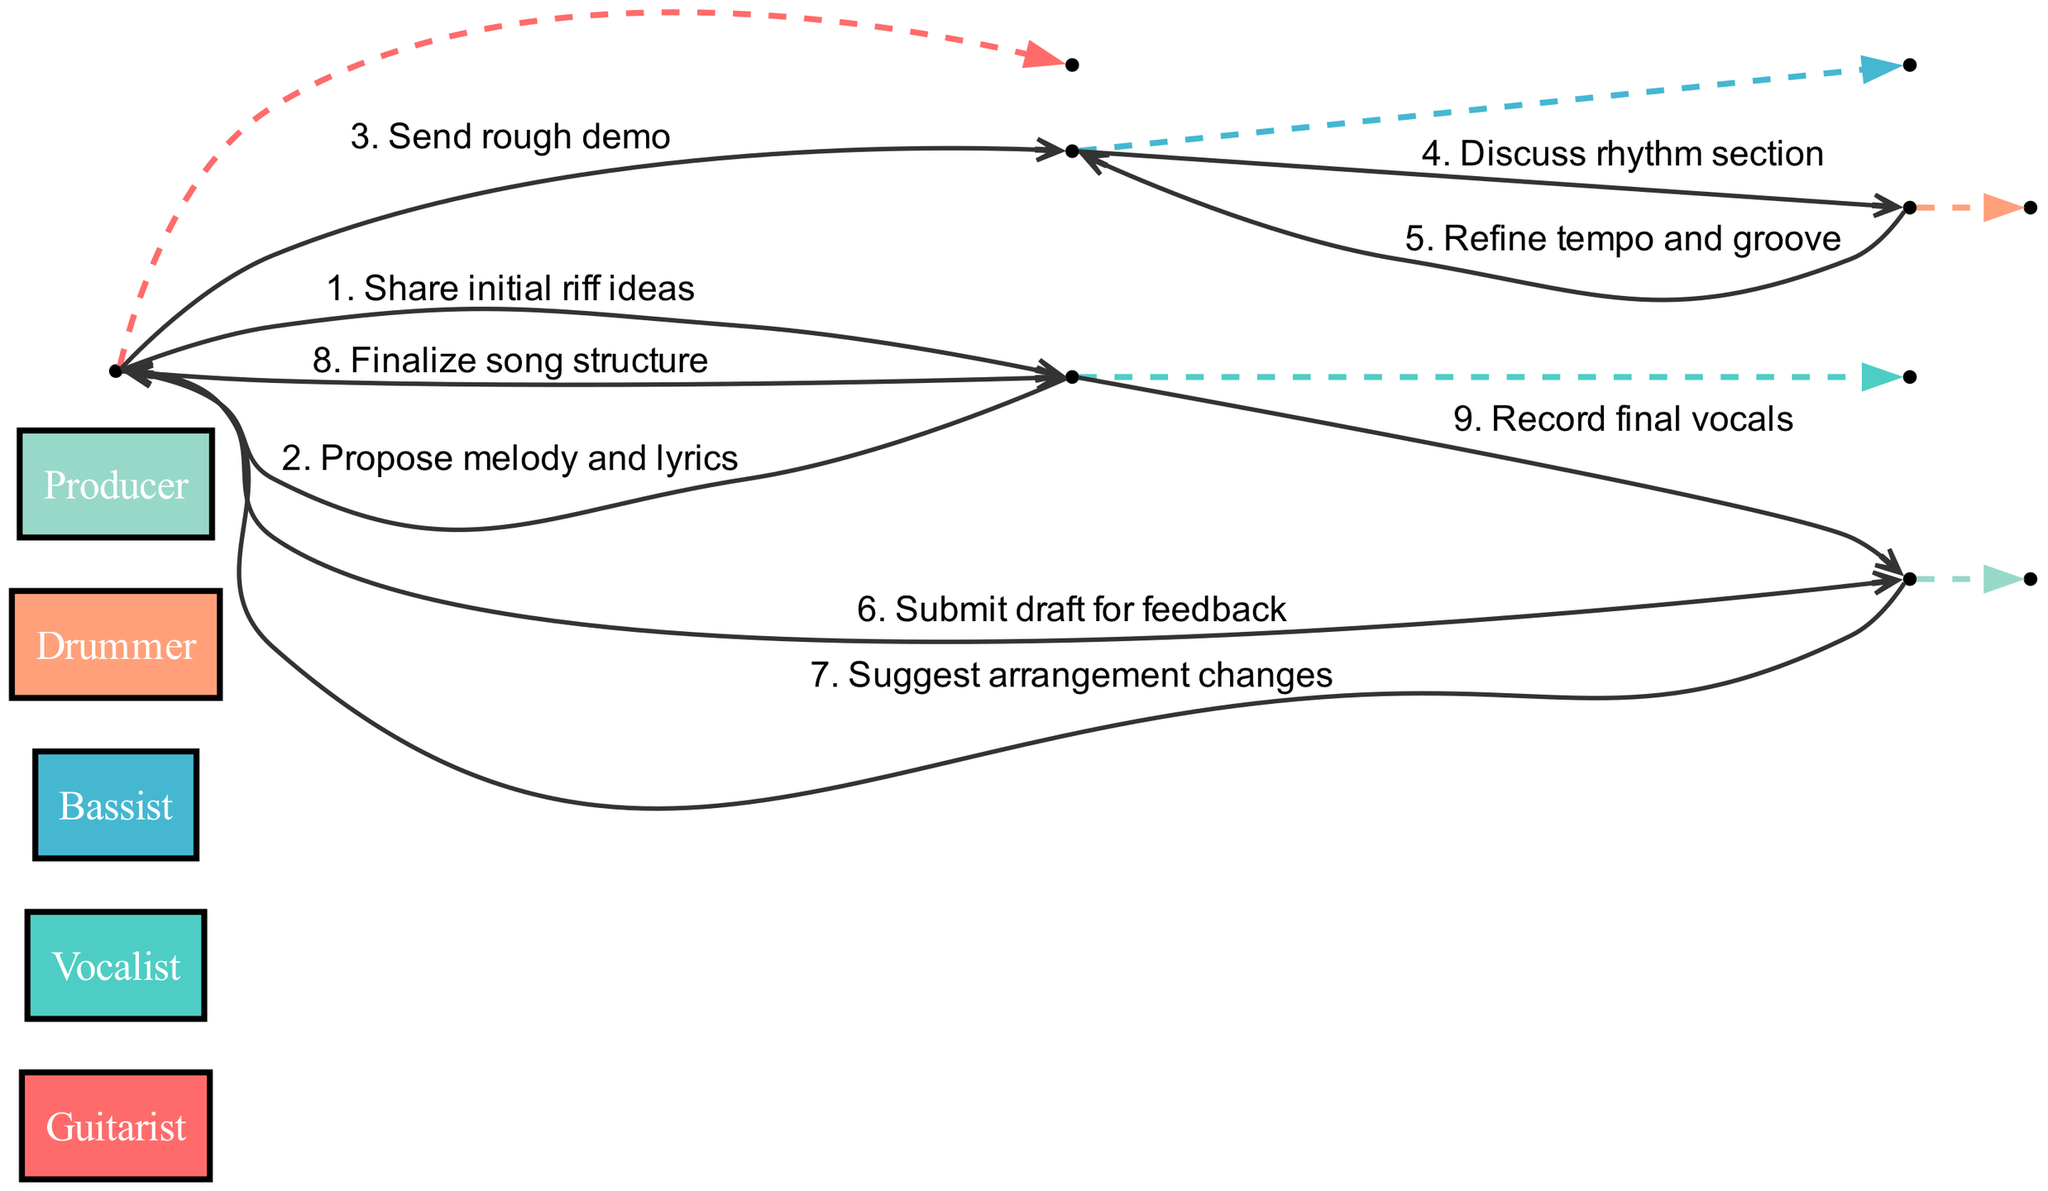What is the first message in the sequence? The first message is from the Guitarist to the Vocalist, indicating that the Guitarist shares initial riff ideas.
Answer: Share initial riff ideas How many actors are involved in the collaboration? There are five actors involved in the collaboration, which are the Guitarist, Vocalist, Bassist, Drummer, and Producer.
Answer: Five Who proposes the melody and lyrics? The Vocalist is the one who proposes the melody and lyrics to the Guitarist.
Answer: Vocalist What is the fifth message in the sequence? The fifth message is about the Drummer refining the tempo and groove after discussing the rhythm section with the Bassist.
Answer: Refine tempo and groove Which actor sends a rough demo? The Guitarist sends the rough demo to the Bassist as part of the collaboration workflow.
Answer: Guitarist What is the final action taken by the Vocalist? The final action taken by the Vocalist is to record the final vocals after receiving the finalized song structure.
Answer: Record final vocals Which actor receives feedback from the Producer? The Guitarist submits a draft for feedback to the Producer. Thus, the Guitarist receives feedback.
Answer: Guitarist What number message indicates the discussion of the rhythm section? The discussion of the rhythm section is indicated as the fourth message in the sequence.
Answer: Four How does the Guitarist communicate with the Producer? The Guitarist communicates with the Producer by submitting a draft for feedback.
Answer: Submit draft for feedback 